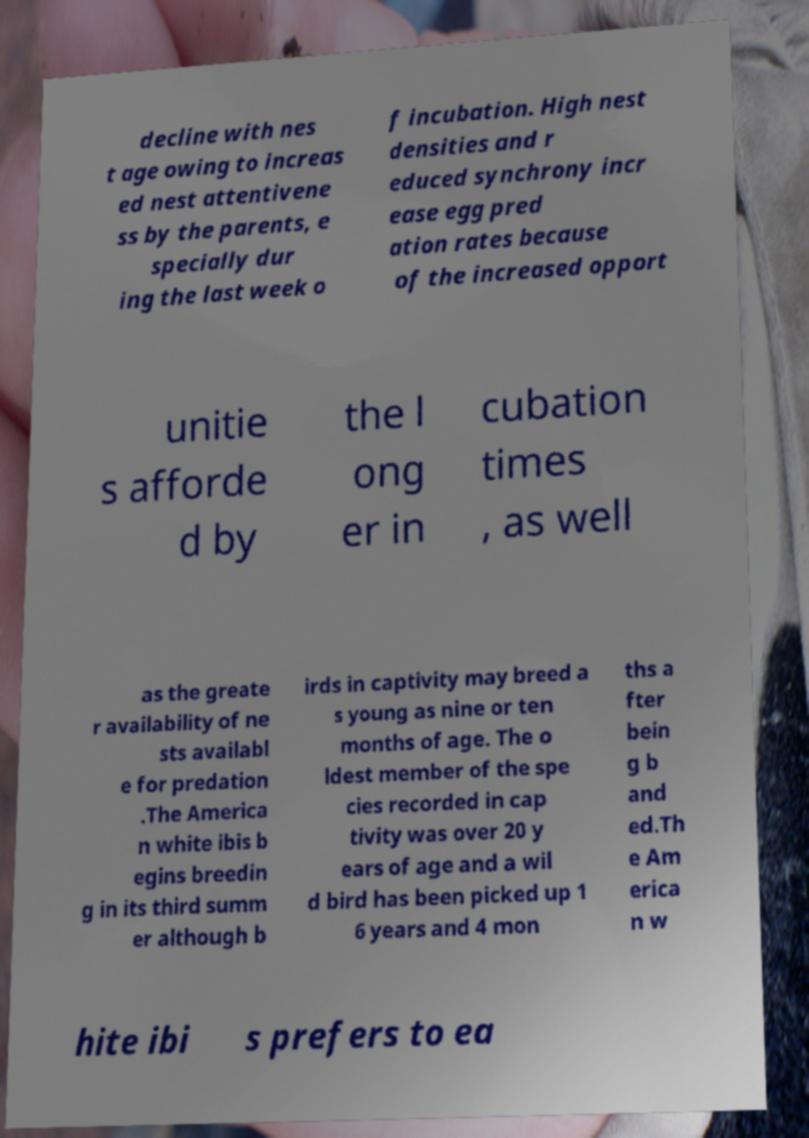There's text embedded in this image that I need extracted. Can you transcribe it verbatim? decline with nes t age owing to increas ed nest attentivene ss by the parents, e specially dur ing the last week o f incubation. High nest densities and r educed synchrony incr ease egg pred ation rates because of the increased opport unitie s afforde d by the l ong er in cubation times , as well as the greate r availability of ne sts availabl e for predation .The America n white ibis b egins breedin g in its third summ er although b irds in captivity may breed a s young as nine or ten months of age. The o ldest member of the spe cies recorded in cap tivity was over 20 y ears of age and a wil d bird has been picked up 1 6 years and 4 mon ths a fter bein g b and ed.Th e Am erica n w hite ibi s prefers to ea 